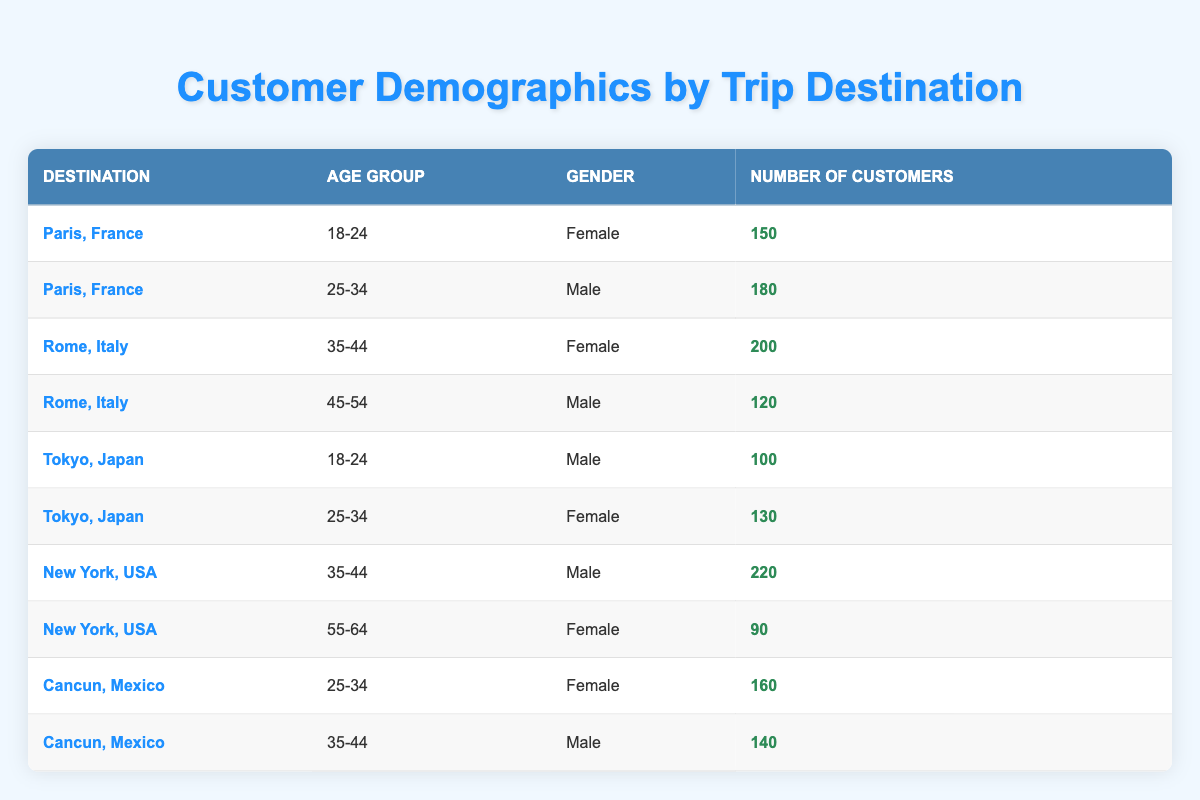What is the number of female customers traveling to Paris, France in the age group 18-24? From the table, under the destination "Paris, France", in the age group "18-24", there is a row indicating 150 female customers.
Answer: 150 How many male customers are there in total for New York, USA? In the table, for "New York, USA", male customers can be found under the age groups 35-44. The number of male customers is 220. Thus, the total number of male customers is 220.
Answer: 220 Is the number of customers traveling to Rome, Italy more than those traveling to Cancun, Mexico? For "Rome, Italy", there are two groups: 200 customers in age group 35-44 and 120 in age group 45-54, totaling 320 customers. For "Cancun, Mexico", there are 160 customers in age group 25-34 and 140 in age group 35-44, totaling 300 customers. Since 320 is greater than 300, the answer is yes.
Answer: Yes What is the average number of customers traveling to Tokyo, Japan across both age groups? For "Tokyo, Japan", there are 100 male customers in the age group 18-24 and 130 female customers in the age group 25-34. The total number is 100 + 130 = 230. There are two age groups, so the average is 230/2 = 115.
Answer: 115 In which destination do males aged 35-44 have the highest number of customers? Looking at the table, "New York, USA" has 220 male customers in the age group 35-44, while "Cancun, Mexico" has 140 male customers in the age group 35-44. No other destination has males in this age category that exceed 220. Therefore, the highest is in New York, USA.
Answer: New York, USA How many male customers are there across all destinations in the age group 25-34? In the age group 25-34 across the destinations, for "Paris, France," there are 180 male customers, for "Tokyo, Japan," there are 130 female customers (not included), and for "Cancun, Mexico," there are no males listed. Total male customers in this age group are only from Paris, which is 180.
Answer: 180 Do more females travel to Tokyo, Japan than to Cancun, Mexico? In "Tokyo, Japan", there are 130 female customers in the age group 25-34. For "Cancun, Mexico", there are 160 females in the age group 25-34. Since 130 is less than 160, the answer is no.
Answer: No What is the total number of female customers traveling to all four destinations? The total counts of female customers across destinations are: Paris (150) + Rome (200) + Tokyo (130) + New York (90) + Cancun (160) = 730.
Answer: 730 